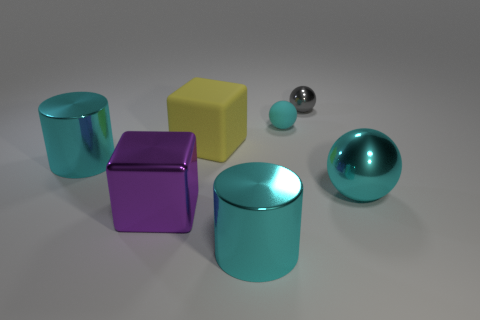The big sphere is what color?
Make the answer very short. Cyan. There is a sphere behind the tiny matte thing; is its color the same as the shiny ball that is in front of the small cyan sphere?
Offer a terse response. No. What is the color of the shiny sphere that is the same size as the yellow object?
Offer a very short reply. Cyan. Are there an equal number of metal things that are to the left of the cyan rubber object and big metallic cubes to the right of the large cyan shiny ball?
Your response must be concise. No. There is a cyan sphere in front of the big cylinder on the left side of the yellow rubber block; what is it made of?
Your answer should be very brief. Metal. How many objects are big gray matte cylinders or big objects?
Offer a terse response. 5. What size is the other matte ball that is the same color as the big ball?
Give a very brief answer. Small. Are there fewer big cubes than yellow things?
Give a very brief answer. No. There is another object that is the same material as the yellow object; what size is it?
Provide a succinct answer. Small. What size is the gray object?
Ensure brevity in your answer.  Small. 